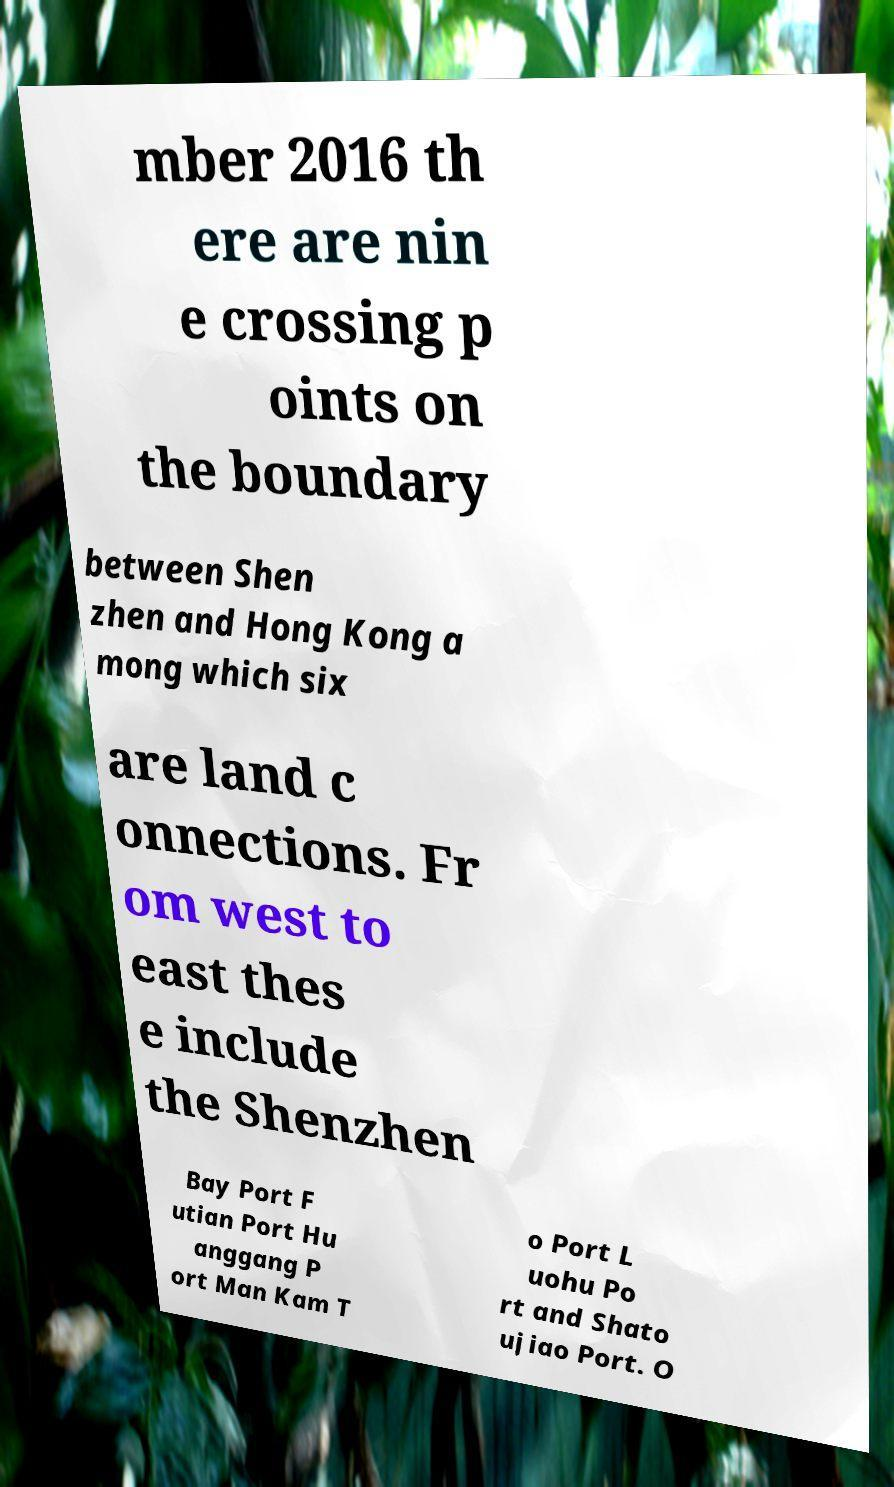Could you extract and type out the text from this image? mber 2016 th ere are nin e crossing p oints on the boundary between Shen zhen and Hong Kong a mong which six are land c onnections. Fr om west to east thes e include the Shenzhen Bay Port F utian Port Hu anggang P ort Man Kam T o Port L uohu Po rt and Shato ujiao Port. O 